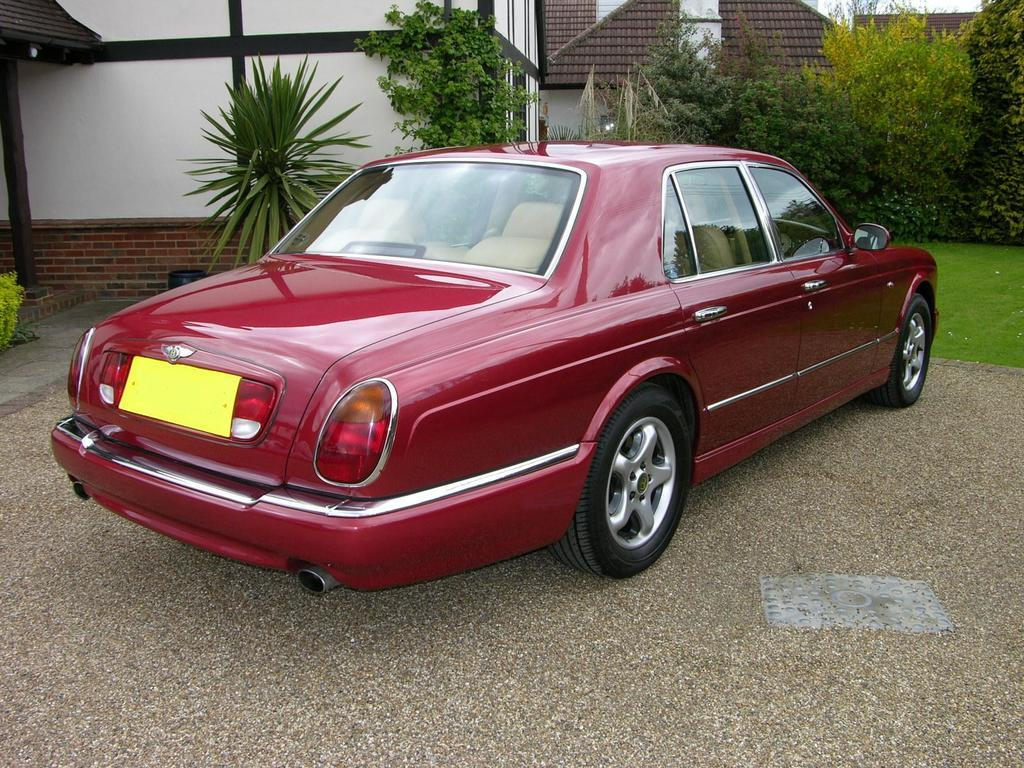What is the main subject of the image? There is a car in the image. Where is the car located? The car is on the road. What can be seen in the background of the image? There are trees, plants, and buildings in the background of the image. How many eggs can be seen in the image? There are no eggs present in the image. What type of yak is visible in the background of the image? There is no yak present in the image. 